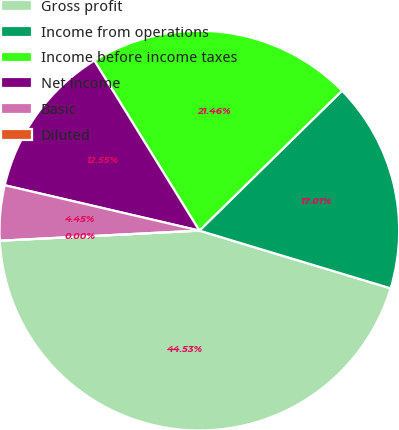Convert chart. <chart><loc_0><loc_0><loc_500><loc_500><pie_chart><fcel>Gross profit<fcel>Income from operations<fcel>Income before income taxes<fcel>Net income<fcel>Basic<fcel>Diluted<nl><fcel>44.53%<fcel>17.01%<fcel>21.46%<fcel>12.55%<fcel>4.45%<fcel>0.0%<nl></chart> 